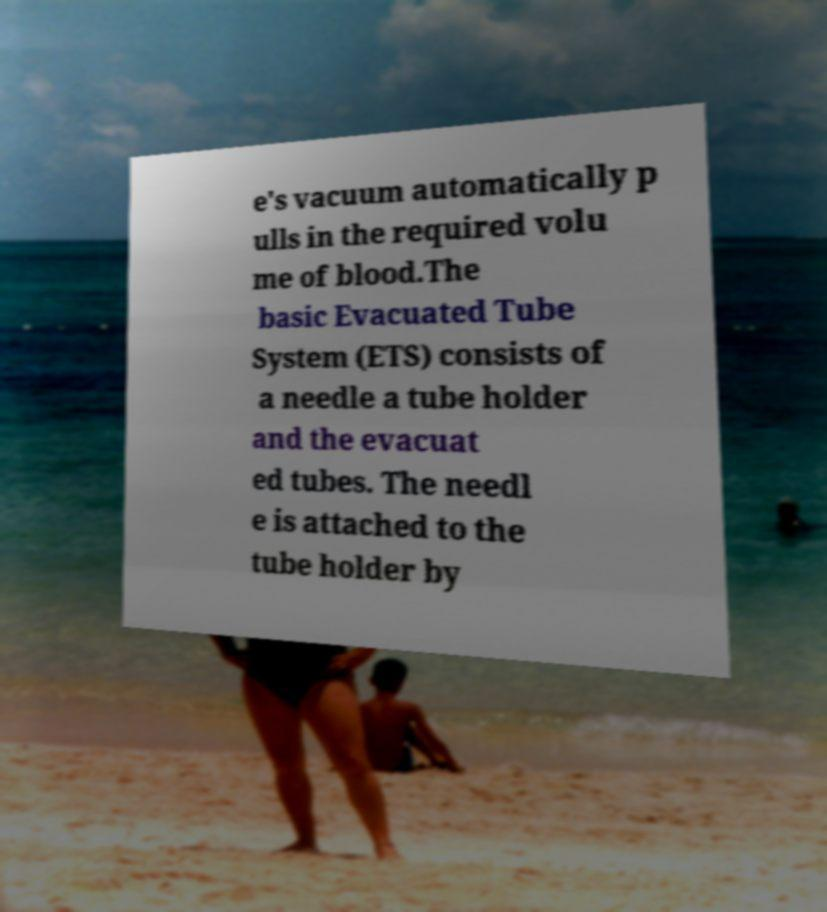For documentation purposes, I need the text within this image transcribed. Could you provide that? e's vacuum automatically p ulls in the required volu me of blood.The basic Evacuated Tube System (ETS) consists of a needle a tube holder and the evacuat ed tubes. The needl e is attached to the tube holder by 